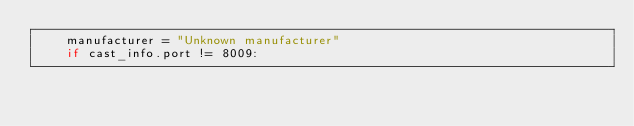<code> <loc_0><loc_0><loc_500><loc_500><_Python_>    manufacturer = "Unknown manufacturer"
    if cast_info.port != 8009:</code> 